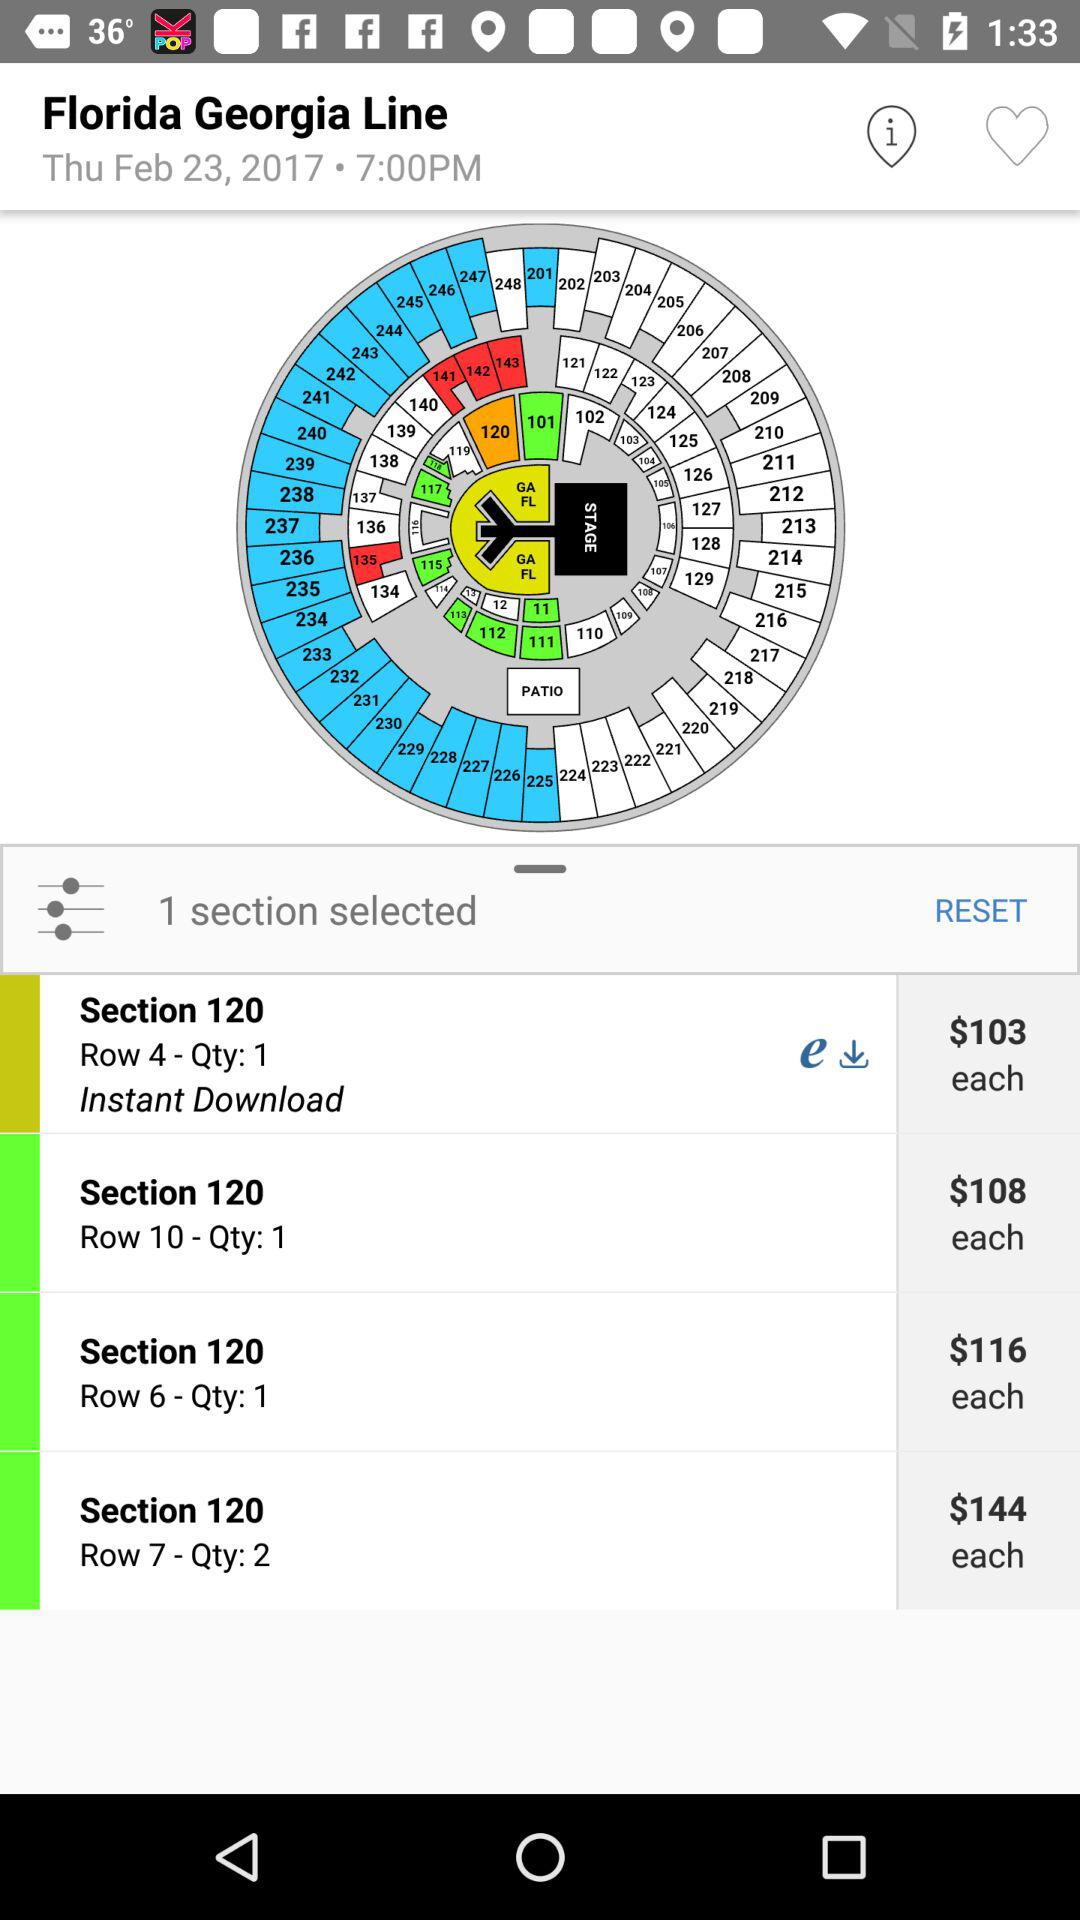What is the cost of each quantity of section 120 in row number 7? The cost is $144. 